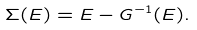Convert formula to latex. <formula><loc_0><loc_0><loc_500><loc_500>\Sigma ( E ) = E - G ^ { - 1 } ( E ) .</formula> 